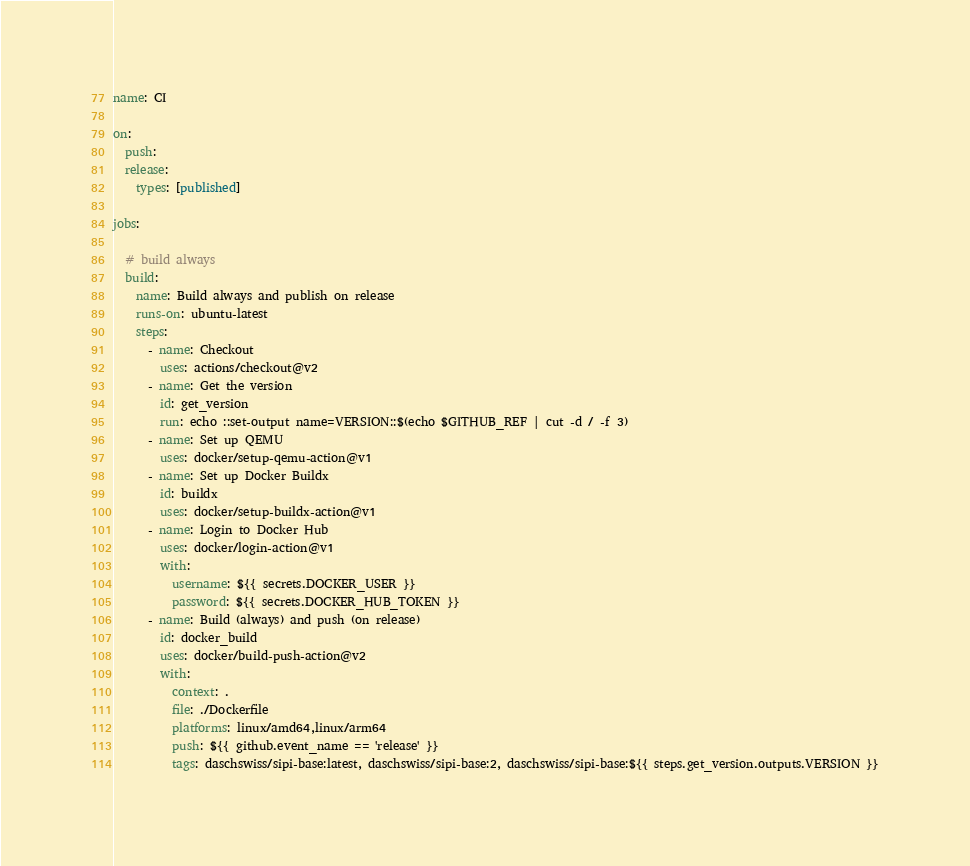Convert code to text. <code><loc_0><loc_0><loc_500><loc_500><_YAML_>name: CI

on:
  push:
  release:
    types: [published]

jobs:
  
  # build always
  build:
    name: Build always and publish on release
    runs-on: ubuntu-latest
    steps:
      - name: Checkout
        uses: actions/checkout@v2
      - name: Get the version
        id: get_version
        run: echo ::set-output name=VERSION::$(echo $GITHUB_REF | cut -d / -f 3)
      - name: Set up QEMU
        uses: docker/setup-qemu-action@v1
      - name: Set up Docker Buildx
        id: buildx
        uses: docker/setup-buildx-action@v1
      - name: Login to Docker Hub
        uses: docker/login-action@v1
        with:
          username: ${{ secrets.DOCKER_USER }}
          password: ${{ secrets.DOCKER_HUB_TOKEN }}
      - name: Build (always) and push (on release)
        id: docker_build
        uses: docker/build-push-action@v2
        with:
          context: .
          file: ./Dockerfile
          platforms: linux/amd64,linux/arm64
          push: ${{ github.event_name == 'release' }}
          tags: daschswiss/sipi-base:latest, daschswiss/sipi-base:2, daschswiss/sipi-base:${{ steps.get_version.outputs.VERSION }}
</code> 